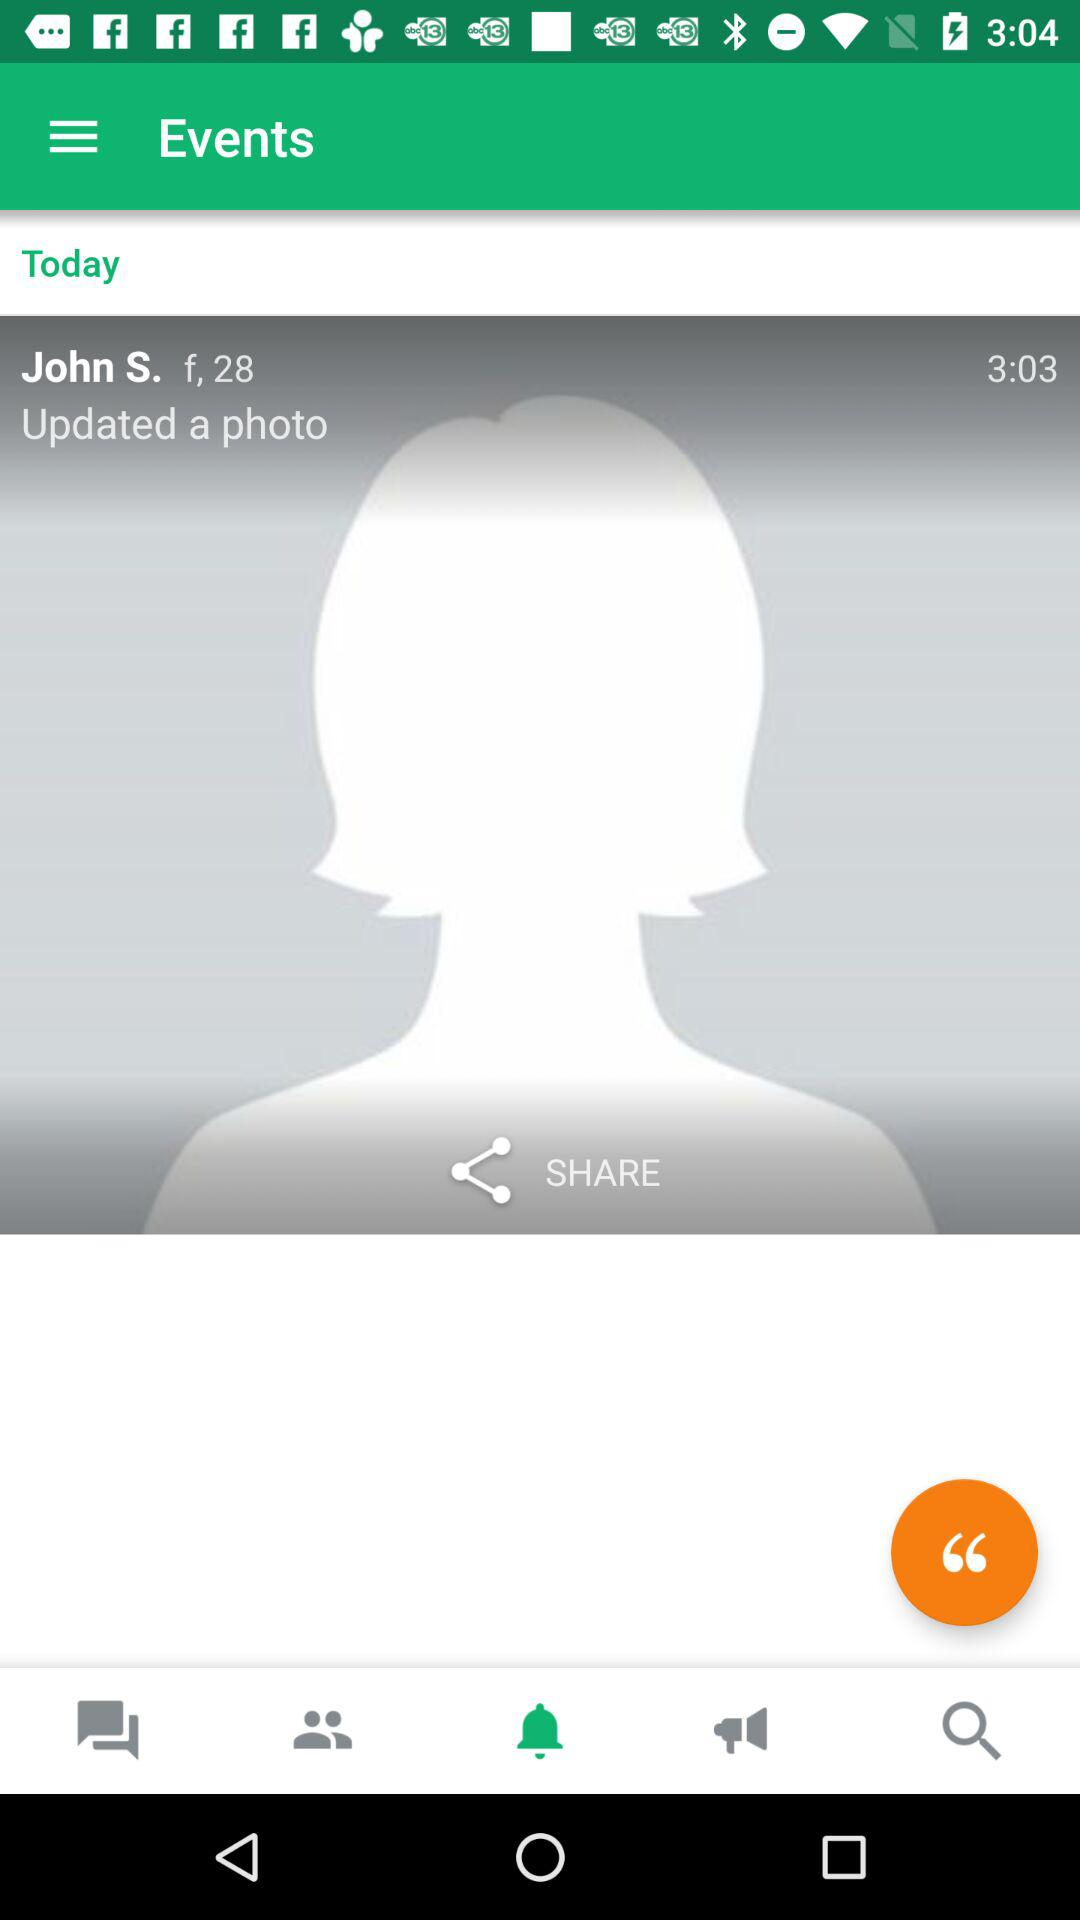What is the mentioned time? The mentioned time is 3:03. 